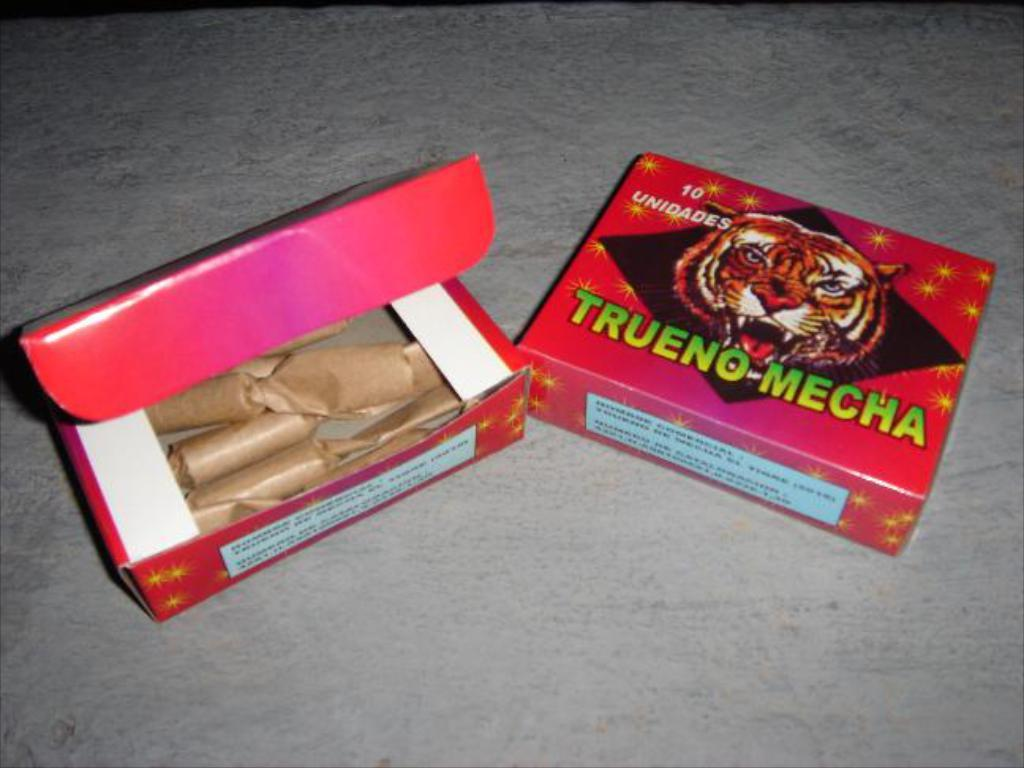What type of containers are present in the image? There are cardboard cartons in the image. Where are the cardboard cartons located? The cardboard cartons are placed on the floor. How many times is the number 7 repeated on the cardboard cartons in the image? There is no mention of the number 7 or any numbers on the cardboard cartons in the image. 